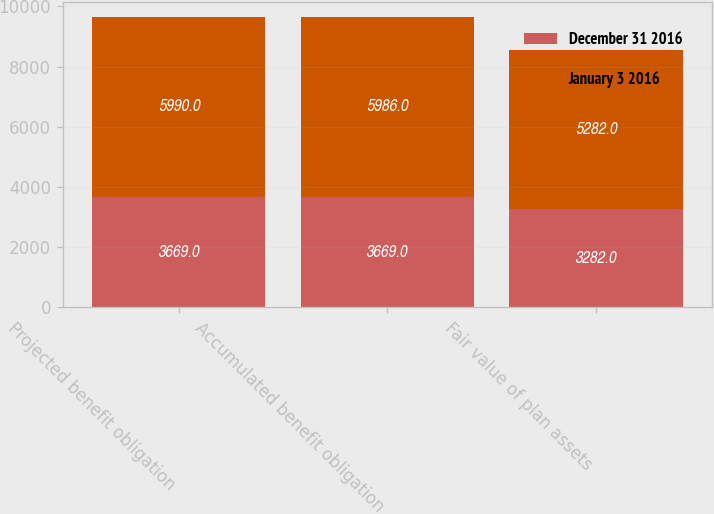Convert chart to OTSL. <chart><loc_0><loc_0><loc_500><loc_500><stacked_bar_chart><ecel><fcel>Projected benefit obligation<fcel>Accumulated benefit obligation<fcel>Fair value of plan assets<nl><fcel>December 31 2016<fcel>3669<fcel>3669<fcel>3282<nl><fcel>January 3 2016<fcel>5990<fcel>5986<fcel>5282<nl></chart> 